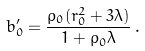Convert formula to latex. <formula><loc_0><loc_0><loc_500><loc_500>b ^ { \prime } _ { 0 } = \frac { \rho _ { 0 } ( r _ { 0 } ^ { 2 } + 3 \lambda ) } { 1 + \rho _ { 0 } \lambda } \, .</formula> 